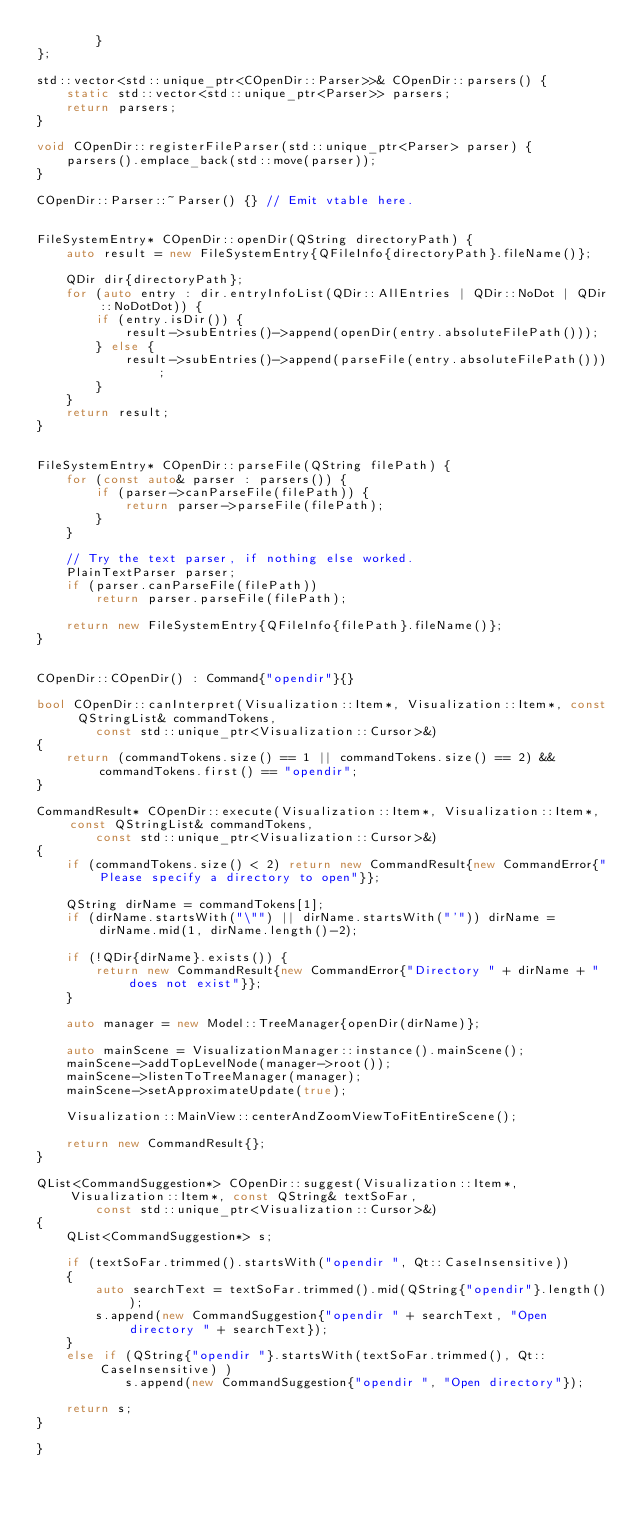<code> <loc_0><loc_0><loc_500><loc_500><_C++_>		}
};

std::vector<std::unique_ptr<COpenDir::Parser>>& COpenDir::parsers() {
	static std::vector<std::unique_ptr<Parser>> parsers;
	return parsers;
}

void COpenDir::registerFileParser(std::unique_ptr<Parser> parser) {
	parsers().emplace_back(std::move(parser));
}

COpenDir::Parser::~Parser() {} // Emit vtable here.


FileSystemEntry* COpenDir::openDir(QString directoryPath) {
	auto result = new FileSystemEntry{QFileInfo{directoryPath}.fileName()};

	QDir dir{directoryPath};
	for (auto entry : dir.entryInfoList(QDir::AllEntries | QDir::NoDot | QDir::NoDotDot)) {
		if (entry.isDir()) {
			result->subEntries()->append(openDir(entry.absoluteFilePath()));
		} else {
			result->subEntries()->append(parseFile(entry.absoluteFilePath()));
		}
	}
	return result;
}


FileSystemEntry* COpenDir::parseFile(QString filePath) {
	for (const auto& parser : parsers()) {
		if (parser->canParseFile(filePath)) {
			return parser->parseFile(filePath);
		}
	}

	// Try the text parser, if nothing else worked.
	PlainTextParser parser;
	if (parser.canParseFile(filePath))
		return parser.parseFile(filePath);

	return new FileSystemEntry{QFileInfo{filePath}.fileName()};
}


COpenDir::COpenDir() : Command{"opendir"}{}

bool COpenDir::canInterpret(Visualization::Item*, Visualization::Item*, const QStringList& commandTokens,
		const std::unique_ptr<Visualization::Cursor>&)
{
	return (commandTokens.size() == 1 || commandTokens.size() == 2) && commandTokens.first() == "opendir";
}

CommandResult* COpenDir::execute(Visualization::Item*, Visualization::Item*, const QStringList& commandTokens,
		const std::unique_ptr<Visualization::Cursor>&)
{
	if (commandTokens.size() < 2) return new CommandResult{new CommandError{"Please specify a directory to open"}};

	QString dirName = commandTokens[1];
	if (dirName.startsWith("\"") || dirName.startsWith("'")) dirName = dirName.mid(1, dirName.length()-2);

	if (!QDir{dirName}.exists()) {
		return new CommandResult{new CommandError{"Directory " + dirName + "does not exist"}};
	}

	auto manager = new Model::TreeManager{openDir(dirName)};

	auto mainScene = VisualizationManager::instance().mainScene();
	mainScene->addTopLevelNode(manager->root());
	mainScene->listenToTreeManager(manager);
	mainScene->setApproximateUpdate(true);

	Visualization::MainView::centerAndZoomViewToFitEntireScene();

	return new CommandResult{};
}

QList<CommandSuggestion*> COpenDir::suggest(Visualization::Item*, Visualization::Item*, const QString& textSoFar,
		const std::unique_ptr<Visualization::Cursor>&)
{
	QList<CommandSuggestion*> s;

	if (textSoFar.trimmed().startsWith("opendir ", Qt::CaseInsensitive))
	{
		auto searchText = textSoFar.trimmed().mid(QString{"opendir"}.length());
		s.append(new CommandSuggestion{"opendir " + searchText, "Open directory " + searchText});
	}
	else if (QString{"opendir "}.startsWith(textSoFar.trimmed(), Qt::CaseInsensitive) )
			s.append(new CommandSuggestion{"opendir ", "Open directory"});

	return s;
}

}
</code> 